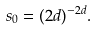Convert formula to latex. <formula><loc_0><loc_0><loc_500><loc_500>s _ { 0 } = ( 2 d ) ^ { - 2 d } .</formula> 